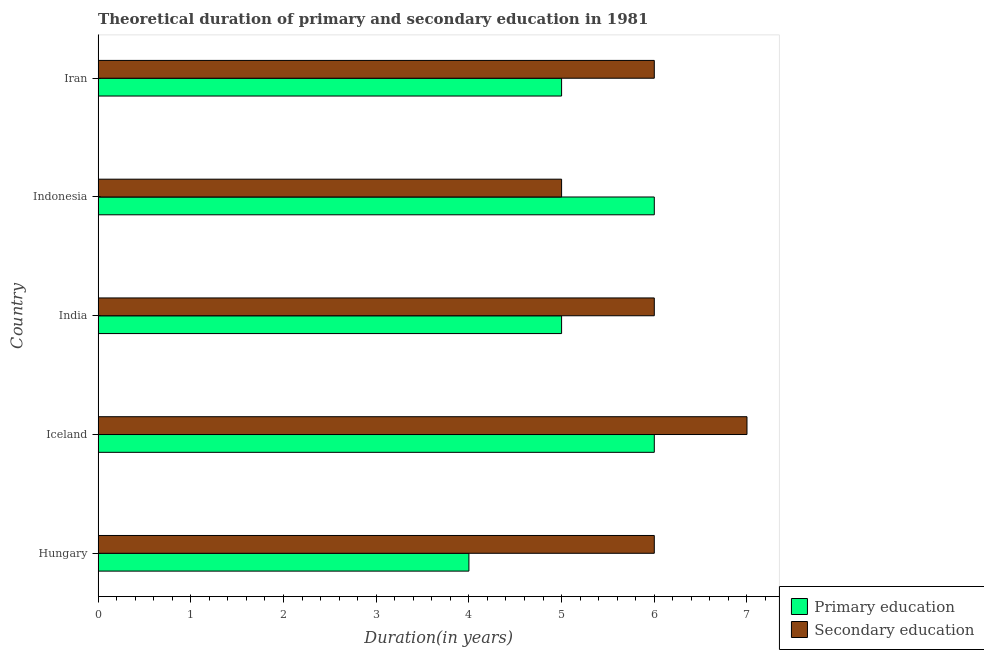How many different coloured bars are there?
Ensure brevity in your answer.  2. How many groups of bars are there?
Give a very brief answer. 5. Are the number of bars on each tick of the Y-axis equal?
Offer a terse response. Yes. How many bars are there on the 2nd tick from the top?
Make the answer very short. 2. What is the label of the 1st group of bars from the top?
Your response must be concise. Iran. In how many cases, is the number of bars for a given country not equal to the number of legend labels?
Make the answer very short. 0. What is the duration of secondary education in Indonesia?
Give a very brief answer. 5. Across all countries, what is the maximum duration of primary education?
Your response must be concise. 6. Across all countries, what is the minimum duration of secondary education?
Give a very brief answer. 5. In which country was the duration of secondary education maximum?
Your answer should be very brief. Iceland. In which country was the duration of primary education minimum?
Keep it short and to the point. Hungary. What is the total duration of primary education in the graph?
Give a very brief answer. 26. What is the difference between the duration of primary education in India and that in Indonesia?
Ensure brevity in your answer.  -1. What is the difference between the duration of secondary education in Indonesia and the duration of primary education in Iceland?
Your answer should be very brief. -1. What is the average duration of secondary education per country?
Make the answer very short. 6. What is the difference between the duration of primary education and duration of secondary education in India?
Provide a short and direct response. -1. What is the ratio of the duration of secondary education in Iceland to that in India?
Offer a terse response. 1.17. Is the duration of secondary education in India less than that in Indonesia?
Provide a short and direct response. No. What is the difference between the highest and the second highest duration of secondary education?
Your response must be concise. 1. What is the difference between the highest and the lowest duration of primary education?
Make the answer very short. 2. What does the 1st bar from the top in Iran represents?
Keep it short and to the point. Secondary education. What does the 1st bar from the bottom in Iceland represents?
Ensure brevity in your answer.  Primary education. How many bars are there?
Provide a succinct answer. 10. Are all the bars in the graph horizontal?
Provide a short and direct response. Yes. How many countries are there in the graph?
Provide a short and direct response. 5. How many legend labels are there?
Give a very brief answer. 2. What is the title of the graph?
Offer a very short reply. Theoretical duration of primary and secondary education in 1981. Does "IMF nonconcessional" appear as one of the legend labels in the graph?
Provide a succinct answer. No. What is the label or title of the X-axis?
Offer a very short reply. Duration(in years). What is the label or title of the Y-axis?
Make the answer very short. Country. What is the Duration(in years) in Secondary education in Hungary?
Your answer should be compact. 6. What is the Duration(in years) of Primary education in Iceland?
Make the answer very short. 6. What is the Duration(in years) of Secondary education in Iceland?
Your answer should be compact. 7. What is the Duration(in years) in Secondary education in Indonesia?
Keep it short and to the point. 5. What is the Duration(in years) in Primary education in Iran?
Provide a short and direct response. 5. What is the Duration(in years) of Secondary education in Iran?
Offer a very short reply. 6. Across all countries, what is the maximum Duration(in years) in Primary education?
Keep it short and to the point. 6. What is the difference between the Duration(in years) in Secondary education in Hungary and that in Iceland?
Provide a succinct answer. -1. What is the difference between the Duration(in years) in Secondary education in Hungary and that in Iran?
Your answer should be compact. 0. What is the difference between the Duration(in years) of Primary education in Iceland and that in Indonesia?
Offer a very short reply. 0. What is the difference between the Duration(in years) in Primary education in Indonesia and that in Iran?
Keep it short and to the point. 1. What is the difference between the Duration(in years) in Primary education in Hungary and the Duration(in years) in Secondary education in India?
Make the answer very short. -2. What is the difference between the Duration(in years) of Primary education in Hungary and the Duration(in years) of Secondary education in Indonesia?
Your answer should be very brief. -1. What is the difference between the Duration(in years) of Primary education in Hungary and the Duration(in years) of Secondary education in Iran?
Your answer should be compact. -2. What is the difference between the Duration(in years) of Primary education in Iceland and the Duration(in years) of Secondary education in Indonesia?
Make the answer very short. 1. What is the difference between the Duration(in years) in Primary education in Iceland and the Duration(in years) in Secondary education in Iran?
Your answer should be compact. 0. What is the difference between the Duration(in years) of Primary education in India and the Duration(in years) of Secondary education in Iran?
Keep it short and to the point. -1. What is the difference between the Duration(in years) of Primary education in Indonesia and the Duration(in years) of Secondary education in Iran?
Your response must be concise. 0. What is the average Duration(in years) in Secondary education per country?
Give a very brief answer. 6. What is the difference between the Duration(in years) of Primary education and Duration(in years) of Secondary education in India?
Your response must be concise. -1. What is the difference between the Duration(in years) in Primary education and Duration(in years) in Secondary education in Iran?
Offer a very short reply. -1. What is the ratio of the Duration(in years) of Secondary education in Hungary to that in Iceland?
Offer a very short reply. 0.86. What is the ratio of the Duration(in years) of Primary education in Hungary to that in Iran?
Provide a succinct answer. 0.8. What is the ratio of the Duration(in years) in Secondary education in Iceland to that in India?
Your response must be concise. 1.17. What is the ratio of the Duration(in years) of Secondary education in Iceland to that in Indonesia?
Ensure brevity in your answer.  1.4. What is the ratio of the Duration(in years) in Primary education in Iceland to that in Iran?
Keep it short and to the point. 1.2. What is the ratio of the Duration(in years) in Primary education in India to that in Indonesia?
Your response must be concise. 0.83. What is the ratio of the Duration(in years) in Secondary education in India to that in Indonesia?
Give a very brief answer. 1.2. What is the ratio of the Duration(in years) of Primary education in India to that in Iran?
Provide a succinct answer. 1. What is the ratio of the Duration(in years) of Primary education in Indonesia to that in Iran?
Your response must be concise. 1.2. What is the ratio of the Duration(in years) of Secondary education in Indonesia to that in Iran?
Make the answer very short. 0.83. What is the difference between the highest and the lowest Duration(in years) of Primary education?
Your response must be concise. 2. 